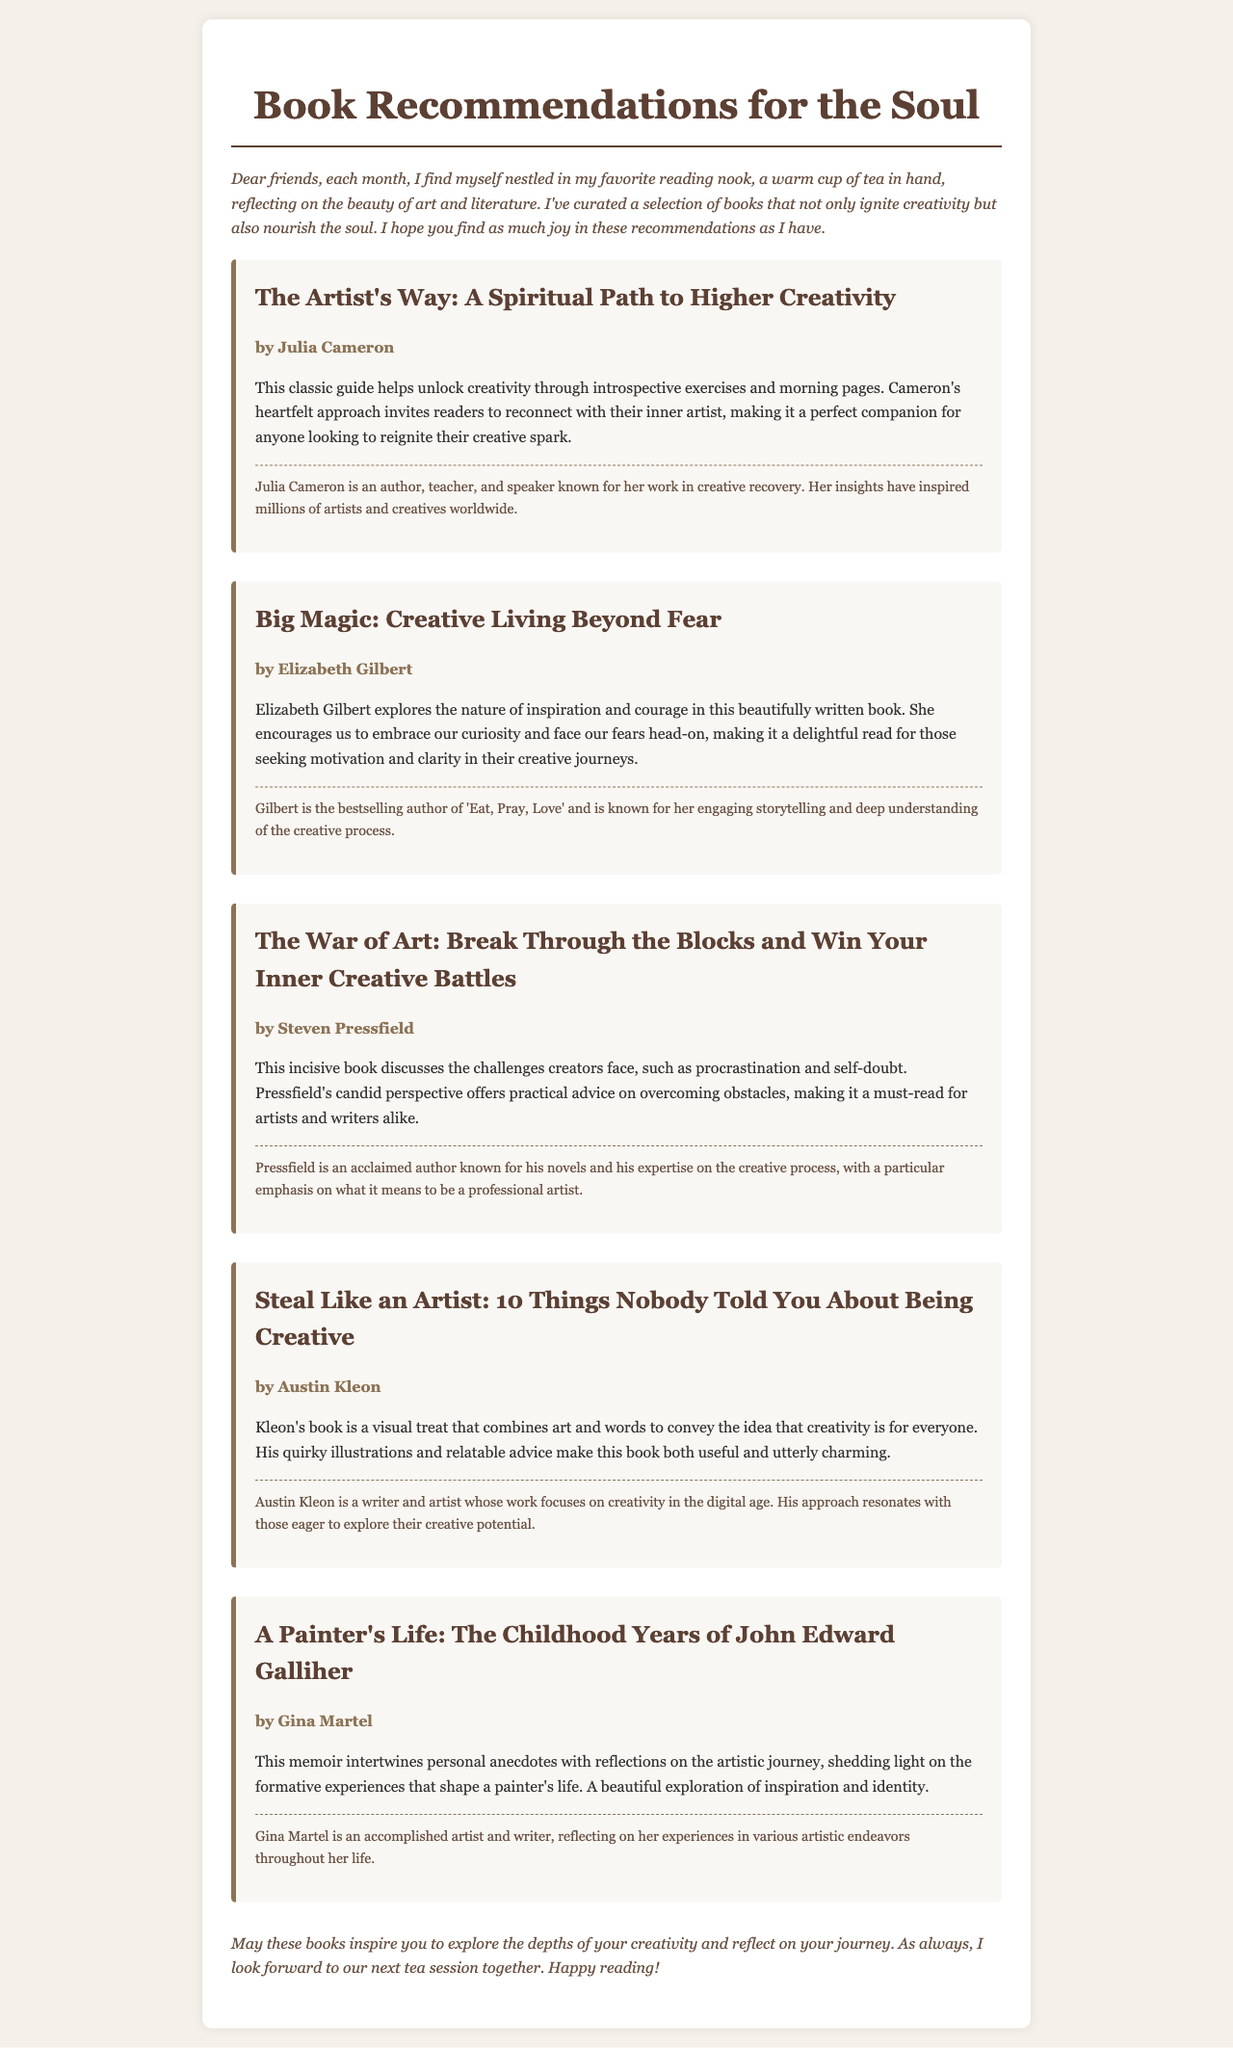What is the title of the first book recommended? The title of the first book is mentioned in the document and is "The Artist's Way: A Spiritual Path to Higher Creativity."
Answer: The Artist's Way: A Spiritual Path to Higher Creativity Who is the author of "Big Magic"? The author of "Big Magic" is listed in the document as Elizabeth Gilbert.
Answer: Elizabeth Gilbert How many books are recommended in total? There are five books listed in the document under book recommendations.
Answer: Five What genre do all the recommended books belong to? The document indicates that all the recommended books inspire creativity and reflection, suggesting they belong to the genre of art and literature.
Answer: Art and literature Which author is known for "Eat, Pray, Love"? The author associated with "Eat, Pray, Love" is directly mentioned in the document and is Elizabeth Gilbert.
Answer: Elizabeth Gilbert What type of book is "Steal Like an Artist"? The document describes "Steal Like an Artist" as a visual treat that combines art and words, indicating it is a guide about creativity.
Answer: Guide about creativity Which book discusses overcoming procrastination and self-doubt? The book that tackles procrastination and self-doubt is mentioned as "The War of Art: Break Through the Blocks and Win Your Inner Creative Battles."
Answer: The War of Art: Break Through the Blocks and Win Your Inner Creative Battles What is the nature of the personal anecdotes in "A Painter's Life"? The document mentions that "A Painter's Life" intertwines personal anecdotes with reflections on the artistic journey, suggesting a memoir style.
Answer: Memoir style 